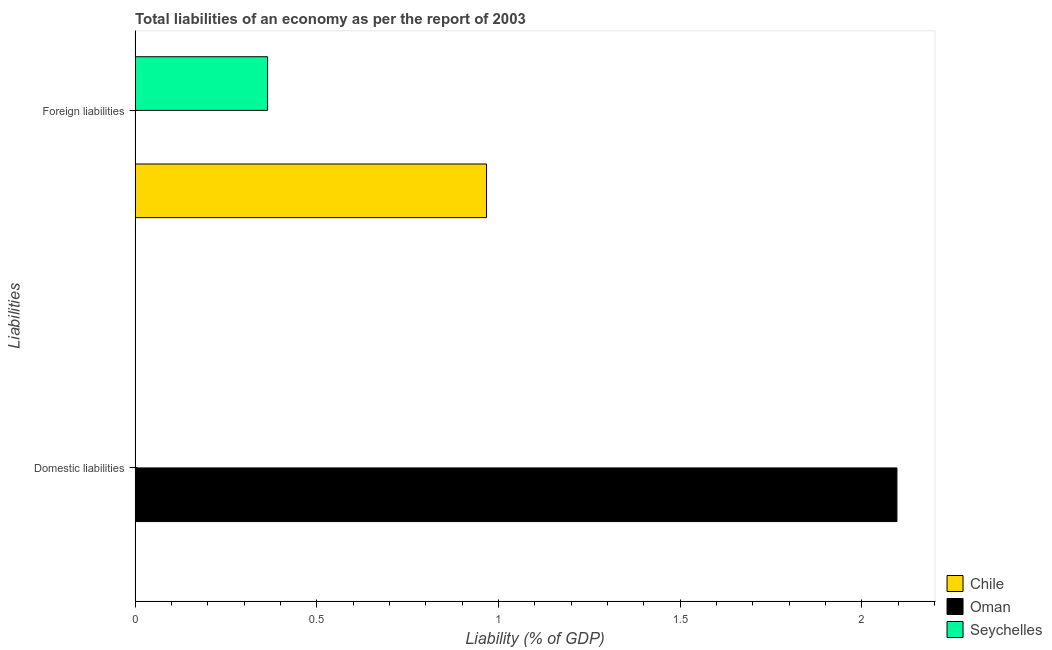How many different coloured bars are there?
Offer a terse response. 3. Are the number of bars per tick equal to the number of legend labels?
Your response must be concise. No. Are the number of bars on each tick of the Y-axis equal?
Provide a succinct answer. No. How many bars are there on the 1st tick from the top?
Your response must be concise. 2. How many bars are there on the 2nd tick from the bottom?
Your answer should be compact. 2. What is the label of the 2nd group of bars from the top?
Keep it short and to the point. Domestic liabilities. What is the incurrence of foreign liabilities in Oman?
Give a very brief answer. 0. Across all countries, what is the maximum incurrence of domestic liabilities?
Your answer should be compact. 2.1. Across all countries, what is the minimum incurrence of domestic liabilities?
Keep it short and to the point. 0. In which country was the incurrence of domestic liabilities maximum?
Your answer should be very brief. Oman. What is the total incurrence of foreign liabilities in the graph?
Ensure brevity in your answer.  1.33. What is the difference between the incurrence of foreign liabilities in Chile and that in Seychelles?
Your response must be concise. 0.6. What is the average incurrence of domestic liabilities per country?
Provide a succinct answer. 0.7. In how many countries, is the incurrence of domestic liabilities greater than the average incurrence of domestic liabilities taken over all countries?
Your answer should be compact. 1. Are the values on the major ticks of X-axis written in scientific E-notation?
Your response must be concise. No. Does the graph contain any zero values?
Offer a terse response. Yes. Does the graph contain grids?
Your answer should be compact. No. Where does the legend appear in the graph?
Your answer should be very brief. Bottom right. How many legend labels are there?
Your answer should be very brief. 3. What is the title of the graph?
Your answer should be very brief. Total liabilities of an economy as per the report of 2003. Does "Montenegro" appear as one of the legend labels in the graph?
Keep it short and to the point. No. What is the label or title of the X-axis?
Your response must be concise. Liability (% of GDP). What is the label or title of the Y-axis?
Your answer should be very brief. Liabilities. What is the Liability (% of GDP) in Chile in Domestic liabilities?
Your answer should be very brief. 0. What is the Liability (% of GDP) in Oman in Domestic liabilities?
Provide a short and direct response. 2.1. What is the Liability (% of GDP) of Seychelles in Domestic liabilities?
Your answer should be very brief. 0. What is the Liability (% of GDP) in Chile in Foreign liabilities?
Ensure brevity in your answer.  0.97. What is the Liability (% of GDP) in Seychelles in Foreign liabilities?
Your answer should be compact. 0.36. Across all Liabilities, what is the maximum Liability (% of GDP) of Chile?
Offer a very short reply. 0.97. Across all Liabilities, what is the maximum Liability (% of GDP) in Oman?
Your answer should be compact. 2.1. Across all Liabilities, what is the maximum Liability (% of GDP) of Seychelles?
Keep it short and to the point. 0.36. Across all Liabilities, what is the minimum Liability (% of GDP) of Chile?
Offer a very short reply. 0. What is the total Liability (% of GDP) in Chile in the graph?
Your response must be concise. 0.97. What is the total Liability (% of GDP) in Oman in the graph?
Your response must be concise. 2.1. What is the total Liability (% of GDP) in Seychelles in the graph?
Your answer should be very brief. 0.36. What is the difference between the Liability (% of GDP) in Oman in Domestic liabilities and the Liability (% of GDP) in Seychelles in Foreign liabilities?
Ensure brevity in your answer.  1.73. What is the average Liability (% of GDP) of Chile per Liabilities?
Your answer should be compact. 0.48. What is the average Liability (% of GDP) in Oman per Liabilities?
Your answer should be compact. 1.05. What is the average Liability (% of GDP) in Seychelles per Liabilities?
Give a very brief answer. 0.18. What is the difference between the Liability (% of GDP) in Chile and Liability (% of GDP) in Seychelles in Foreign liabilities?
Your answer should be very brief. 0.6. What is the difference between the highest and the lowest Liability (% of GDP) in Chile?
Offer a very short reply. 0.97. What is the difference between the highest and the lowest Liability (% of GDP) in Oman?
Offer a terse response. 2.1. What is the difference between the highest and the lowest Liability (% of GDP) in Seychelles?
Your answer should be very brief. 0.36. 